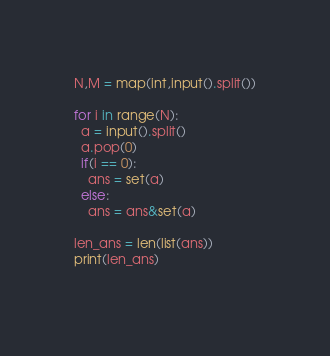<code> <loc_0><loc_0><loc_500><loc_500><_Python_>N,M = map(int,input().split())

for i in range(N):
  a = input().split()
  a.pop(0)
  if(i == 0):
    ans = set(a)
  else:
    ans = ans&set(a)
    
len_ans = len(list(ans))
print(len_ans)
      </code> 